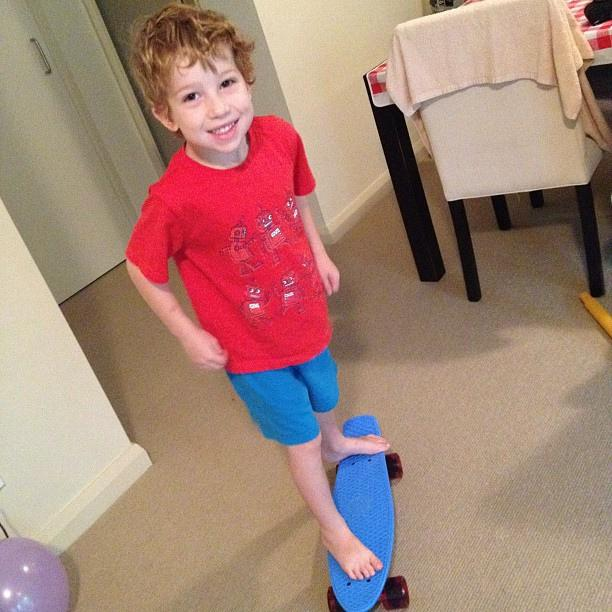The color of the boy's outfit matches the colors of the costume of what super hero? Please explain your reasoning. spider man. Spider man is known for red. 